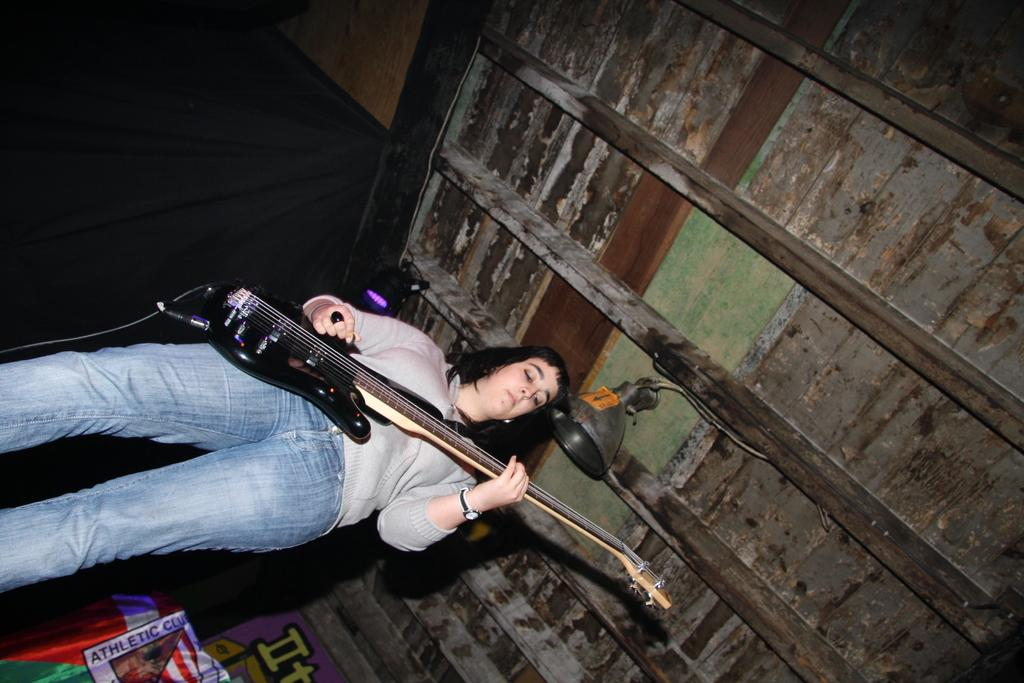Who is the main subject in the image? There is a lady in the image. What is the lady holding in the image? The lady is holding a guitar. What might the lady be doing with the guitar? The lady may be playing the guitar. What else can be seen in the image besides the lady and the guitar? There is a banner in the image. What can be inferred about the building from the image? The roof appears to be old. How much dust is visible on the tramp in the image? There is no tramp present in the image, so it is not possible to determine the amount of dust on it. 